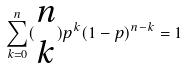Convert formula to latex. <formula><loc_0><loc_0><loc_500><loc_500>\sum _ { k = 0 } ^ { n } ( \begin{matrix} n \\ k \end{matrix} ) p ^ { k } ( 1 - p ) ^ { n - k } = 1</formula> 